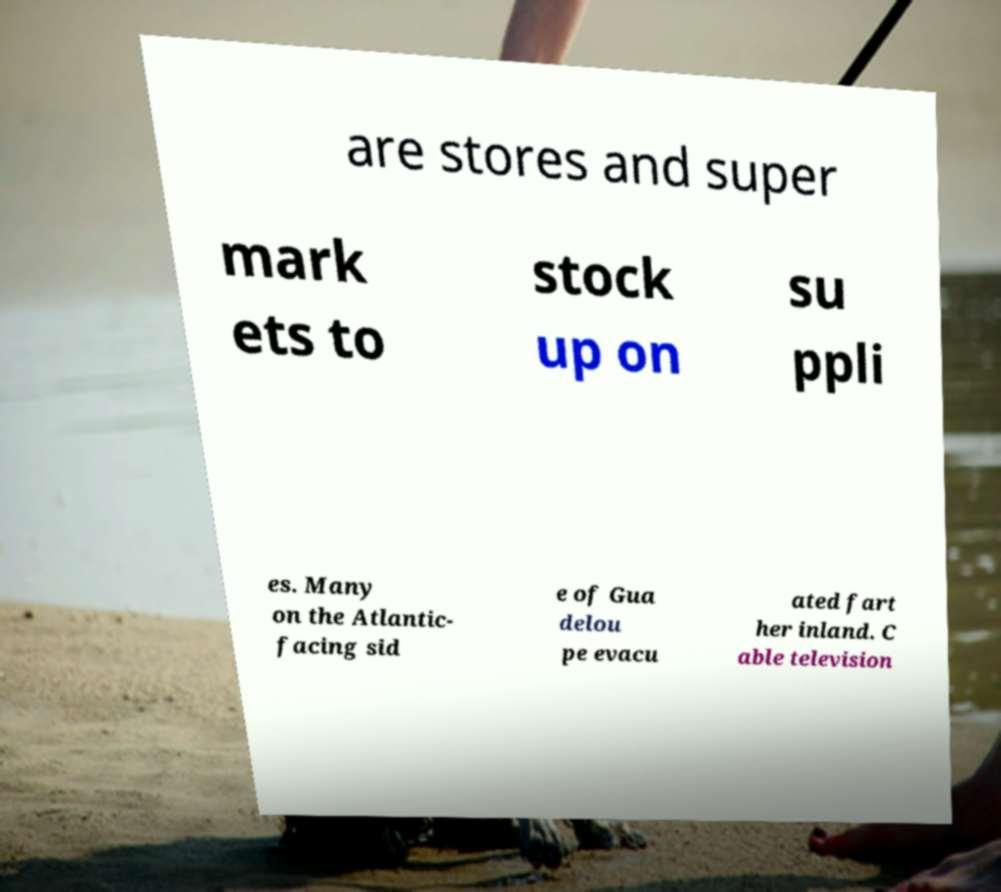What messages or text are displayed in this image? I need them in a readable, typed format. are stores and super mark ets to stock up on su ppli es. Many on the Atlantic- facing sid e of Gua delou pe evacu ated fart her inland. C able television 